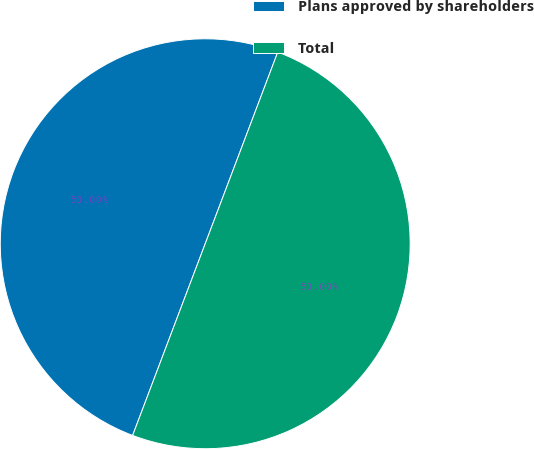<chart> <loc_0><loc_0><loc_500><loc_500><pie_chart><fcel>Plans approved by shareholders<fcel>Total<nl><fcel>50.0%<fcel>50.0%<nl></chart> 